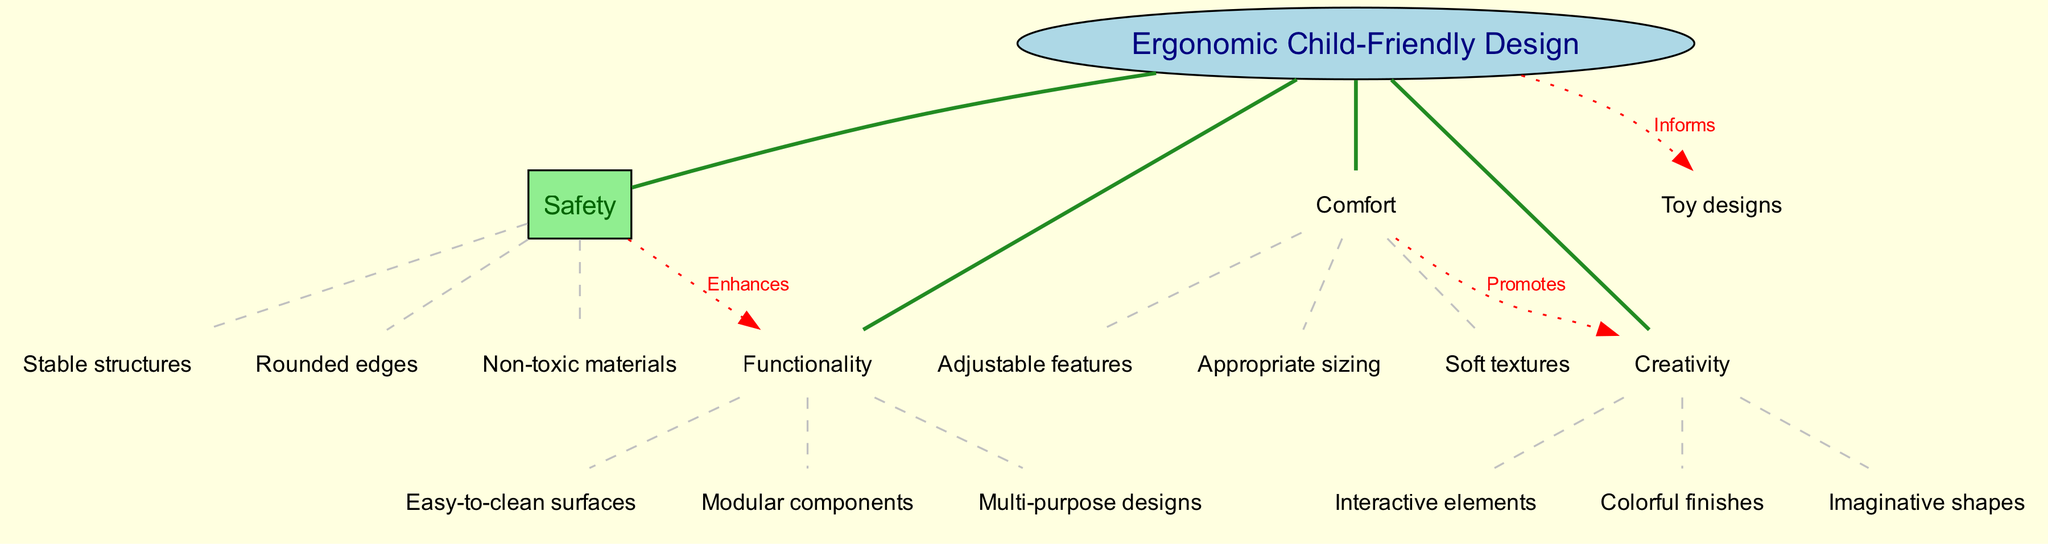What is the central concept of the diagram? The central concept is presented in the middle of the diagram, clearly labeled as "Ergonomic Child-Friendly Design." It serves as the foundational idea from which all other branches emerge.
Answer: Ergonomic Child-Friendly Design How many main branches are there in the diagram? The diagram has a total of four main branches: "Safety," "Comfort," "Functionality," and "Creativity." Each branch represents a key aspect of the child-friendly design.
Answer: 4 What does "Safety" enhance according to the diagram? The diagram shows a direct connection labeled "Enhances" from the "Safety" branch to the "Functionality" branch, indicating that safety features contribute positively to functionality.
Answer: Functionality Which sub-branch is associated with "Comfort"? The sub-branch related to "Comfort" includes "Appropriate sizing." This indicates that sizing is an essential aspect of ensuring comfort in furniture and play structures.
Answer: Appropriate sizing What does "Creativity" promote in the diagram? There’s a connection labeled "Promotes" from the "Comfort" branch to the "Creativity" branch, indicating that comfort features contribute to enhancing creative elements in design.
Answer: Creativity What is one of the connections made directly from the "Ergonomic Child-Friendly Design"? The diagram depicts a connection from "Ergonomic Child-Friendly Design" to "Toy designs," labeled "Informs," which shows how the central concept provides insights for designing toys.
Answer: Toy designs Which sub-branch under "Safety" highlights a material characteristic? In the "Safety" branch, the sub-branch "Non-toxic materials" focuses on the type of materials used in creating child-friendly designs ensuring they are safe for children to use.
Answer: Non-toxic materials What type of elements does "Creativity" include in its sub-branches? The "Creativity" branch contains "Interactive elements," which indicates a focus on features that engage children and enhance their play experience through creativity.
Answer: Interactive elements Which term describes features that are easy to maintain in the "Functionality" branch? The sub-branch "Easy-to-clean surfaces" under "Functionality" highlights the importance of maintenance-friendly features in the design of child-friendly furniture and play structures.
Answer: Easy-to-clean surfaces 